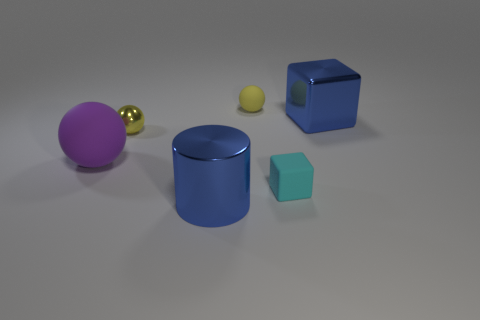Add 3 large things. How many objects exist? 9 Subtract all cylinders. How many objects are left? 5 Subtract all tiny yellow metal balls. Subtract all metallic spheres. How many objects are left? 4 Add 4 blue things. How many blue things are left? 6 Add 5 shiny balls. How many shiny balls exist? 6 Subtract 1 cyan cubes. How many objects are left? 5 